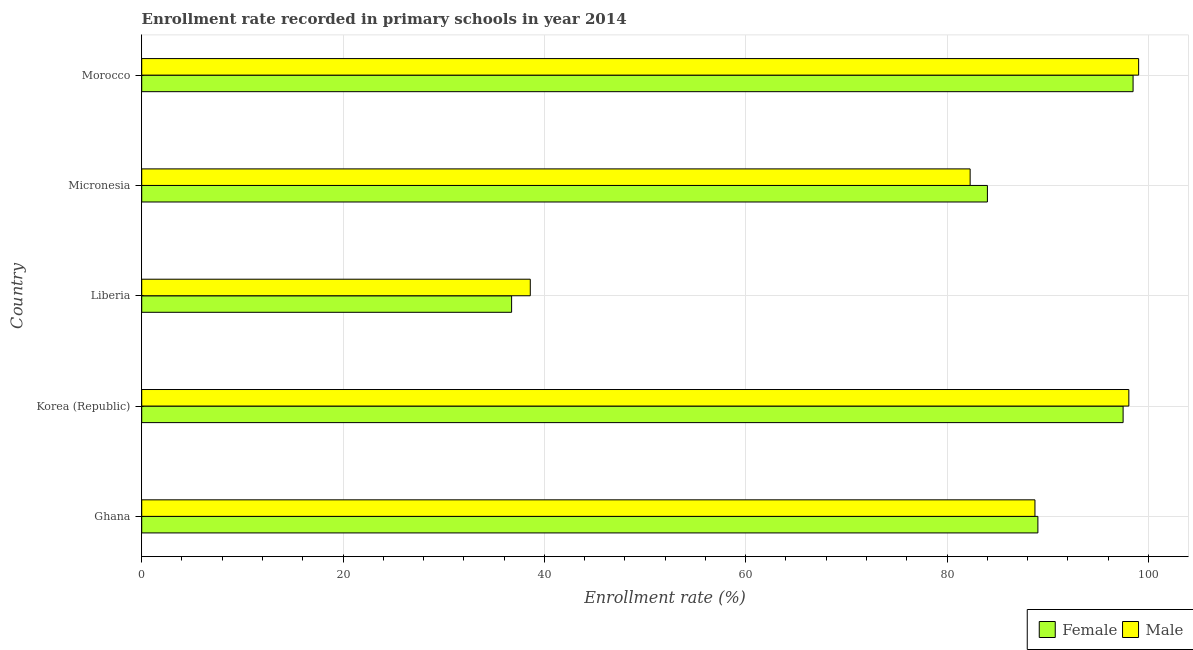How many different coloured bars are there?
Your answer should be very brief. 2. How many groups of bars are there?
Keep it short and to the point. 5. Are the number of bars on each tick of the Y-axis equal?
Offer a very short reply. Yes. How many bars are there on the 1st tick from the bottom?
Provide a short and direct response. 2. What is the label of the 3rd group of bars from the top?
Give a very brief answer. Liberia. What is the enrollment rate of male students in Korea (Republic)?
Provide a succinct answer. 98.06. Across all countries, what is the maximum enrollment rate of female students?
Offer a terse response. 98.48. Across all countries, what is the minimum enrollment rate of female students?
Provide a short and direct response. 36.74. In which country was the enrollment rate of female students maximum?
Give a very brief answer. Morocco. In which country was the enrollment rate of female students minimum?
Keep it short and to the point. Liberia. What is the total enrollment rate of male students in the graph?
Provide a succinct answer. 406.72. What is the difference between the enrollment rate of male students in Ghana and that in Korea (Republic)?
Make the answer very short. -9.33. What is the difference between the enrollment rate of female students in Korea (Republic) and the enrollment rate of male students in Liberia?
Provide a short and direct response. 58.89. What is the average enrollment rate of female students per country?
Give a very brief answer. 81.15. What is the difference between the enrollment rate of male students and enrollment rate of female students in Liberia?
Offer a very short reply. 1.85. What is the ratio of the enrollment rate of male students in Micronesia to that in Morocco?
Ensure brevity in your answer.  0.83. Is the enrollment rate of male students in Micronesia less than that in Morocco?
Offer a terse response. Yes. What is the difference between the highest and the lowest enrollment rate of female students?
Keep it short and to the point. 61.74. In how many countries, is the enrollment rate of male students greater than the average enrollment rate of male students taken over all countries?
Give a very brief answer. 4. Is the sum of the enrollment rate of female students in Korea (Republic) and Liberia greater than the maximum enrollment rate of male students across all countries?
Make the answer very short. Yes. What does the 1st bar from the bottom in Ghana represents?
Your response must be concise. Female. How many bars are there?
Provide a short and direct response. 10. How many countries are there in the graph?
Offer a very short reply. 5. Does the graph contain grids?
Your answer should be very brief. Yes. What is the title of the graph?
Make the answer very short. Enrollment rate recorded in primary schools in year 2014. Does "Export" appear as one of the legend labels in the graph?
Your answer should be compact. No. What is the label or title of the X-axis?
Your response must be concise. Enrollment rate (%). What is the Enrollment rate (%) of Female in Ghana?
Offer a terse response. 89.03. What is the Enrollment rate (%) in Male in Ghana?
Provide a succinct answer. 88.73. What is the Enrollment rate (%) of Female in Korea (Republic)?
Provide a short and direct response. 97.49. What is the Enrollment rate (%) in Male in Korea (Republic)?
Offer a terse response. 98.06. What is the Enrollment rate (%) in Female in Liberia?
Provide a short and direct response. 36.74. What is the Enrollment rate (%) in Male in Liberia?
Provide a succinct answer. 38.6. What is the Enrollment rate (%) in Female in Micronesia?
Make the answer very short. 84.01. What is the Enrollment rate (%) of Male in Micronesia?
Your answer should be very brief. 82.29. What is the Enrollment rate (%) in Female in Morocco?
Keep it short and to the point. 98.48. What is the Enrollment rate (%) of Male in Morocco?
Make the answer very short. 99.03. Across all countries, what is the maximum Enrollment rate (%) of Female?
Your response must be concise. 98.48. Across all countries, what is the maximum Enrollment rate (%) of Male?
Offer a terse response. 99.03. Across all countries, what is the minimum Enrollment rate (%) in Female?
Offer a very short reply. 36.74. Across all countries, what is the minimum Enrollment rate (%) in Male?
Your answer should be very brief. 38.6. What is the total Enrollment rate (%) of Female in the graph?
Provide a succinct answer. 405.75. What is the total Enrollment rate (%) of Male in the graph?
Provide a succinct answer. 406.72. What is the difference between the Enrollment rate (%) of Female in Ghana and that in Korea (Republic)?
Offer a terse response. -8.47. What is the difference between the Enrollment rate (%) of Male in Ghana and that in Korea (Republic)?
Provide a short and direct response. -9.33. What is the difference between the Enrollment rate (%) of Female in Ghana and that in Liberia?
Provide a succinct answer. 52.28. What is the difference between the Enrollment rate (%) in Male in Ghana and that in Liberia?
Make the answer very short. 50.13. What is the difference between the Enrollment rate (%) of Female in Ghana and that in Micronesia?
Provide a succinct answer. 5.02. What is the difference between the Enrollment rate (%) of Male in Ghana and that in Micronesia?
Your response must be concise. 6.44. What is the difference between the Enrollment rate (%) of Female in Ghana and that in Morocco?
Your answer should be compact. -9.46. What is the difference between the Enrollment rate (%) of Male in Ghana and that in Morocco?
Your response must be concise. -10.3. What is the difference between the Enrollment rate (%) in Female in Korea (Republic) and that in Liberia?
Give a very brief answer. 60.75. What is the difference between the Enrollment rate (%) of Male in Korea (Republic) and that in Liberia?
Give a very brief answer. 59.46. What is the difference between the Enrollment rate (%) in Female in Korea (Republic) and that in Micronesia?
Your response must be concise. 13.48. What is the difference between the Enrollment rate (%) in Male in Korea (Republic) and that in Micronesia?
Give a very brief answer. 15.77. What is the difference between the Enrollment rate (%) of Female in Korea (Republic) and that in Morocco?
Your answer should be compact. -0.99. What is the difference between the Enrollment rate (%) in Male in Korea (Republic) and that in Morocco?
Ensure brevity in your answer.  -0.97. What is the difference between the Enrollment rate (%) in Female in Liberia and that in Micronesia?
Provide a succinct answer. -47.27. What is the difference between the Enrollment rate (%) in Male in Liberia and that in Micronesia?
Make the answer very short. -43.7. What is the difference between the Enrollment rate (%) of Female in Liberia and that in Morocco?
Offer a very short reply. -61.74. What is the difference between the Enrollment rate (%) in Male in Liberia and that in Morocco?
Offer a very short reply. -60.43. What is the difference between the Enrollment rate (%) of Female in Micronesia and that in Morocco?
Provide a short and direct response. -14.47. What is the difference between the Enrollment rate (%) of Male in Micronesia and that in Morocco?
Ensure brevity in your answer.  -16.74. What is the difference between the Enrollment rate (%) in Female in Ghana and the Enrollment rate (%) in Male in Korea (Republic)?
Offer a very short reply. -9.04. What is the difference between the Enrollment rate (%) of Female in Ghana and the Enrollment rate (%) of Male in Liberia?
Your answer should be very brief. 50.43. What is the difference between the Enrollment rate (%) in Female in Ghana and the Enrollment rate (%) in Male in Micronesia?
Offer a very short reply. 6.73. What is the difference between the Enrollment rate (%) of Female in Ghana and the Enrollment rate (%) of Male in Morocco?
Your answer should be compact. -10.01. What is the difference between the Enrollment rate (%) of Female in Korea (Republic) and the Enrollment rate (%) of Male in Liberia?
Your answer should be very brief. 58.89. What is the difference between the Enrollment rate (%) of Female in Korea (Republic) and the Enrollment rate (%) of Male in Micronesia?
Your answer should be compact. 15.2. What is the difference between the Enrollment rate (%) of Female in Korea (Republic) and the Enrollment rate (%) of Male in Morocco?
Offer a very short reply. -1.54. What is the difference between the Enrollment rate (%) of Female in Liberia and the Enrollment rate (%) of Male in Micronesia?
Your answer should be very brief. -45.55. What is the difference between the Enrollment rate (%) of Female in Liberia and the Enrollment rate (%) of Male in Morocco?
Ensure brevity in your answer.  -62.29. What is the difference between the Enrollment rate (%) in Female in Micronesia and the Enrollment rate (%) in Male in Morocco?
Offer a terse response. -15.02. What is the average Enrollment rate (%) of Female per country?
Your response must be concise. 81.15. What is the average Enrollment rate (%) of Male per country?
Offer a terse response. 81.34. What is the difference between the Enrollment rate (%) in Female and Enrollment rate (%) in Male in Ghana?
Provide a short and direct response. 0.29. What is the difference between the Enrollment rate (%) in Female and Enrollment rate (%) in Male in Korea (Republic)?
Make the answer very short. -0.57. What is the difference between the Enrollment rate (%) of Female and Enrollment rate (%) of Male in Liberia?
Provide a succinct answer. -1.86. What is the difference between the Enrollment rate (%) in Female and Enrollment rate (%) in Male in Micronesia?
Give a very brief answer. 1.72. What is the difference between the Enrollment rate (%) in Female and Enrollment rate (%) in Male in Morocco?
Your answer should be very brief. -0.55. What is the ratio of the Enrollment rate (%) in Female in Ghana to that in Korea (Republic)?
Provide a short and direct response. 0.91. What is the ratio of the Enrollment rate (%) in Male in Ghana to that in Korea (Republic)?
Provide a succinct answer. 0.9. What is the ratio of the Enrollment rate (%) of Female in Ghana to that in Liberia?
Make the answer very short. 2.42. What is the ratio of the Enrollment rate (%) of Male in Ghana to that in Liberia?
Ensure brevity in your answer.  2.3. What is the ratio of the Enrollment rate (%) in Female in Ghana to that in Micronesia?
Make the answer very short. 1.06. What is the ratio of the Enrollment rate (%) in Male in Ghana to that in Micronesia?
Make the answer very short. 1.08. What is the ratio of the Enrollment rate (%) in Female in Ghana to that in Morocco?
Your response must be concise. 0.9. What is the ratio of the Enrollment rate (%) of Male in Ghana to that in Morocco?
Ensure brevity in your answer.  0.9. What is the ratio of the Enrollment rate (%) of Female in Korea (Republic) to that in Liberia?
Your response must be concise. 2.65. What is the ratio of the Enrollment rate (%) of Male in Korea (Republic) to that in Liberia?
Offer a very short reply. 2.54. What is the ratio of the Enrollment rate (%) of Female in Korea (Republic) to that in Micronesia?
Provide a succinct answer. 1.16. What is the ratio of the Enrollment rate (%) in Male in Korea (Republic) to that in Micronesia?
Provide a short and direct response. 1.19. What is the ratio of the Enrollment rate (%) in Male in Korea (Republic) to that in Morocco?
Your response must be concise. 0.99. What is the ratio of the Enrollment rate (%) of Female in Liberia to that in Micronesia?
Your response must be concise. 0.44. What is the ratio of the Enrollment rate (%) in Male in Liberia to that in Micronesia?
Ensure brevity in your answer.  0.47. What is the ratio of the Enrollment rate (%) in Female in Liberia to that in Morocco?
Make the answer very short. 0.37. What is the ratio of the Enrollment rate (%) in Male in Liberia to that in Morocco?
Your answer should be very brief. 0.39. What is the ratio of the Enrollment rate (%) in Female in Micronesia to that in Morocco?
Offer a very short reply. 0.85. What is the ratio of the Enrollment rate (%) of Male in Micronesia to that in Morocco?
Provide a short and direct response. 0.83. What is the difference between the highest and the second highest Enrollment rate (%) in Female?
Keep it short and to the point. 0.99. What is the difference between the highest and the second highest Enrollment rate (%) of Male?
Your answer should be compact. 0.97. What is the difference between the highest and the lowest Enrollment rate (%) of Female?
Offer a very short reply. 61.74. What is the difference between the highest and the lowest Enrollment rate (%) in Male?
Keep it short and to the point. 60.43. 